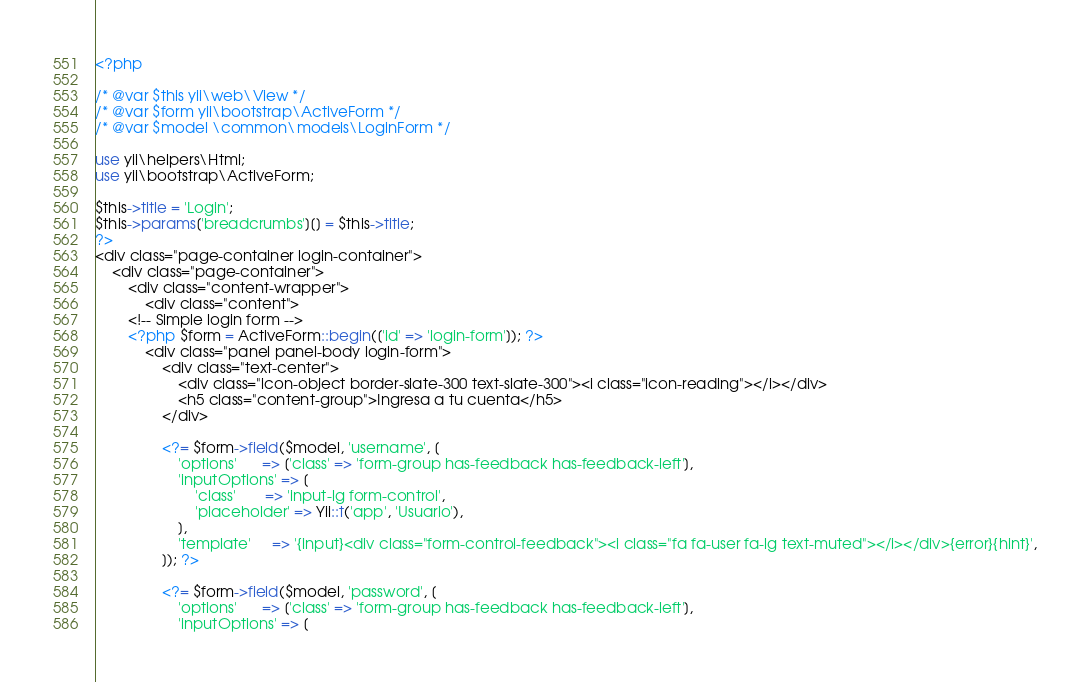<code> <loc_0><loc_0><loc_500><loc_500><_PHP_><?php

/* @var $this yii\web\View */
/* @var $form yii\bootstrap\ActiveForm */
/* @var $model \common\models\LoginForm */

use yii\helpers\Html;
use yii\bootstrap\ActiveForm;

$this->title = 'Login';
$this->params['breadcrumbs'][] = $this->title;
?>
<div class="page-container login-container">
	<div class="page-container">
		<div class="content-wrapper">
			<div class="content">
        <!-- Simple login form -->
        <?php $form = ActiveForm::begin(['id' => 'login-form']); ?>
            <div class="panel panel-body login-form">
                <div class="text-center">
                    <div class="icon-object border-slate-300 text-slate-300"><i class="icon-reading"></i></div>
                    <h5 class="content-group">Ingresa a tu cuenta</h5>
                </div>

                <?= $form->field($model, 'username', [
                    'options'      => ['class' => 'form-group has-feedback has-feedback-left'],
                    'inputOptions' => [
                        'class'       => 'input-lg form-control',
                        'placeholder' => Yii::t('app', 'Usuario'),
                    ],
                    'template'     => '{input}<div class="form-control-feedback"><i class="fa fa-user fa-lg text-muted"></i></div>{error}{hint}',
                ]); ?>

                <?= $form->field($model, 'password', [
                    'options'      => ['class' => 'form-group has-feedback has-feedback-left'],
                    'inputOptions' => [</code> 